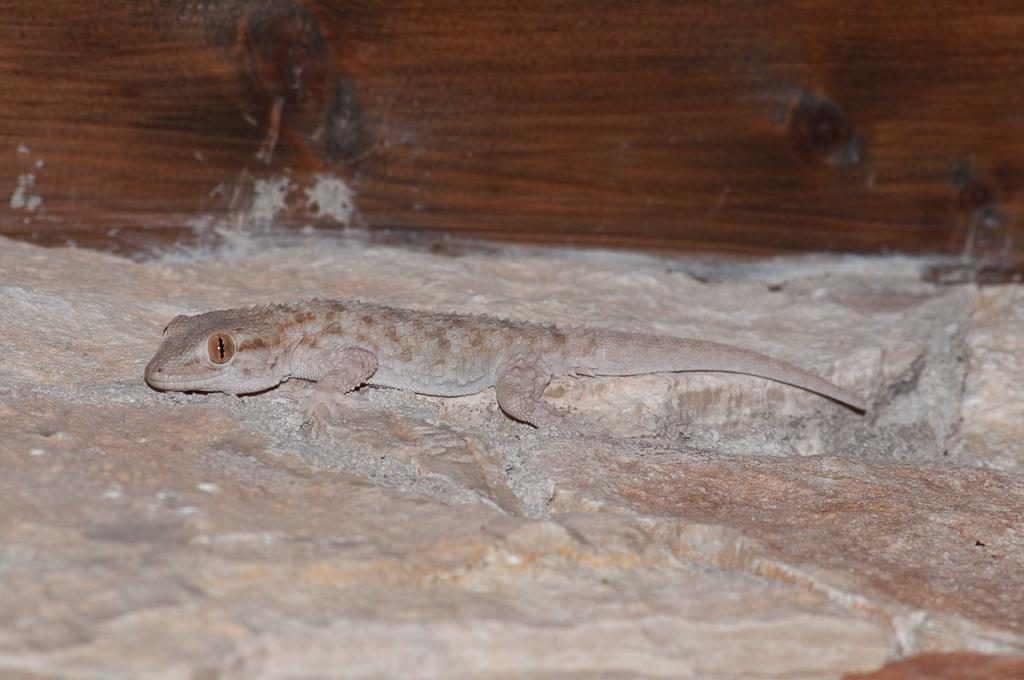What type of animal is in the image? There is a lizard in the image. Where is the lizard located? The lizard is on a rock. What can be seen in the background of the image? There is a brown-colored wall in the background of the image. How many ducks are sitting on the tree in the image? There is no tree or ducks present in the image; it features a lizard on a rock with a brown-colored wall in the background. 